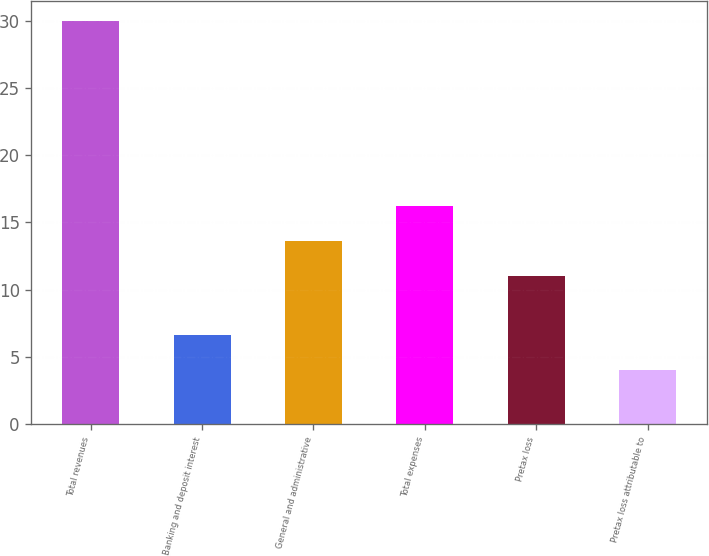Convert chart to OTSL. <chart><loc_0><loc_0><loc_500><loc_500><bar_chart><fcel>Total revenues<fcel>Banking and deposit interest<fcel>General and administrative<fcel>Total expenses<fcel>Pretax loss<fcel>Pretax loss attributable to<nl><fcel>30<fcel>6.6<fcel>13.6<fcel>16.2<fcel>11<fcel>4<nl></chart> 